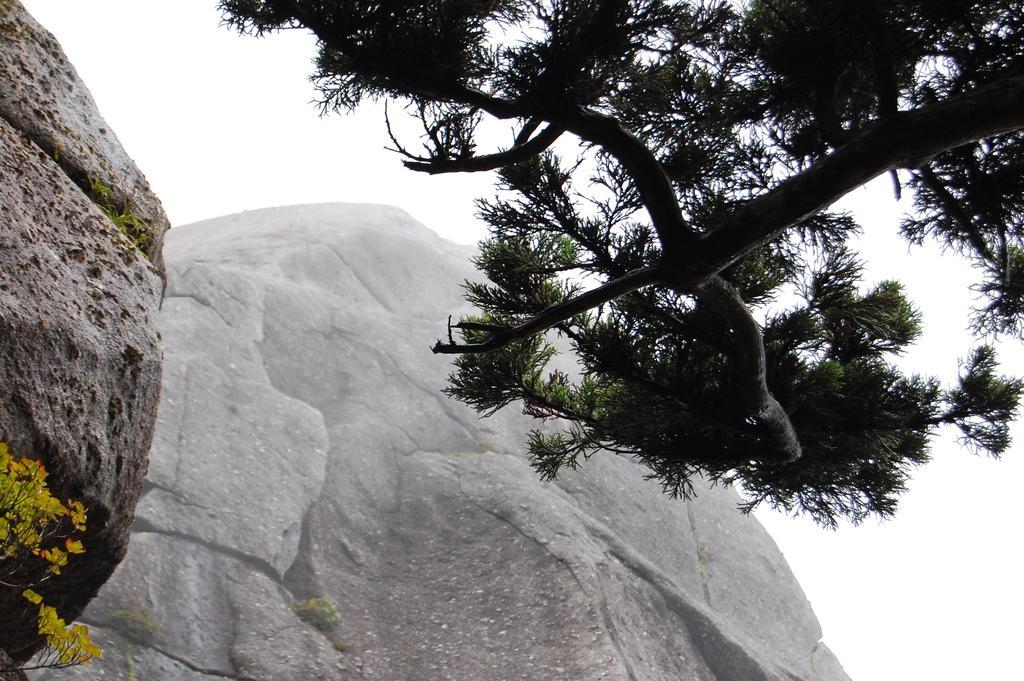Describe this image in one or two sentences. In the image there is a tree in the front and behind it there are hills and above its sky. 